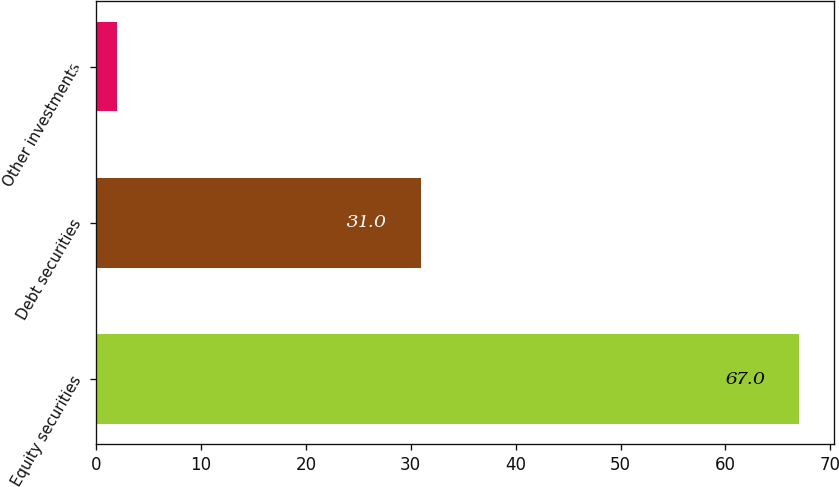Convert chart to OTSL. <chart><loc_0><loc_0><loc_500><loc_500><bar_chart><fcel>Equity securities<fcel>Debt securities<fcel>Other investments<nl><fcel>67<fcel>31<fcel>2<nl></chart> 